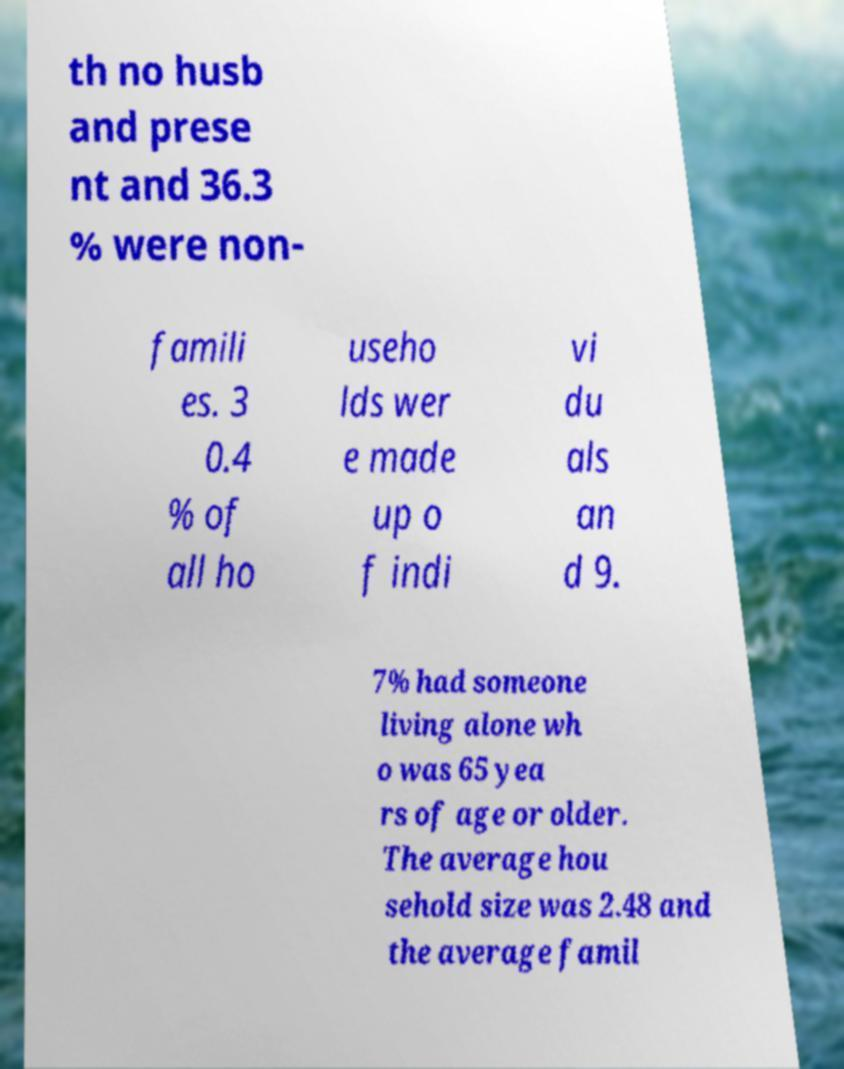For documentation purposes, I need the text within this image transcribed. Could you provide that? th no husb and prese nt and 36.3 % were non- famili es. 3 0.4 % of all ho useho lds wer e made up o f indi vi du als an d 9. 7% had someone living alone wh o was 65 yea rs of age or older. The average hou sehold size was 2.48 and the average famil 